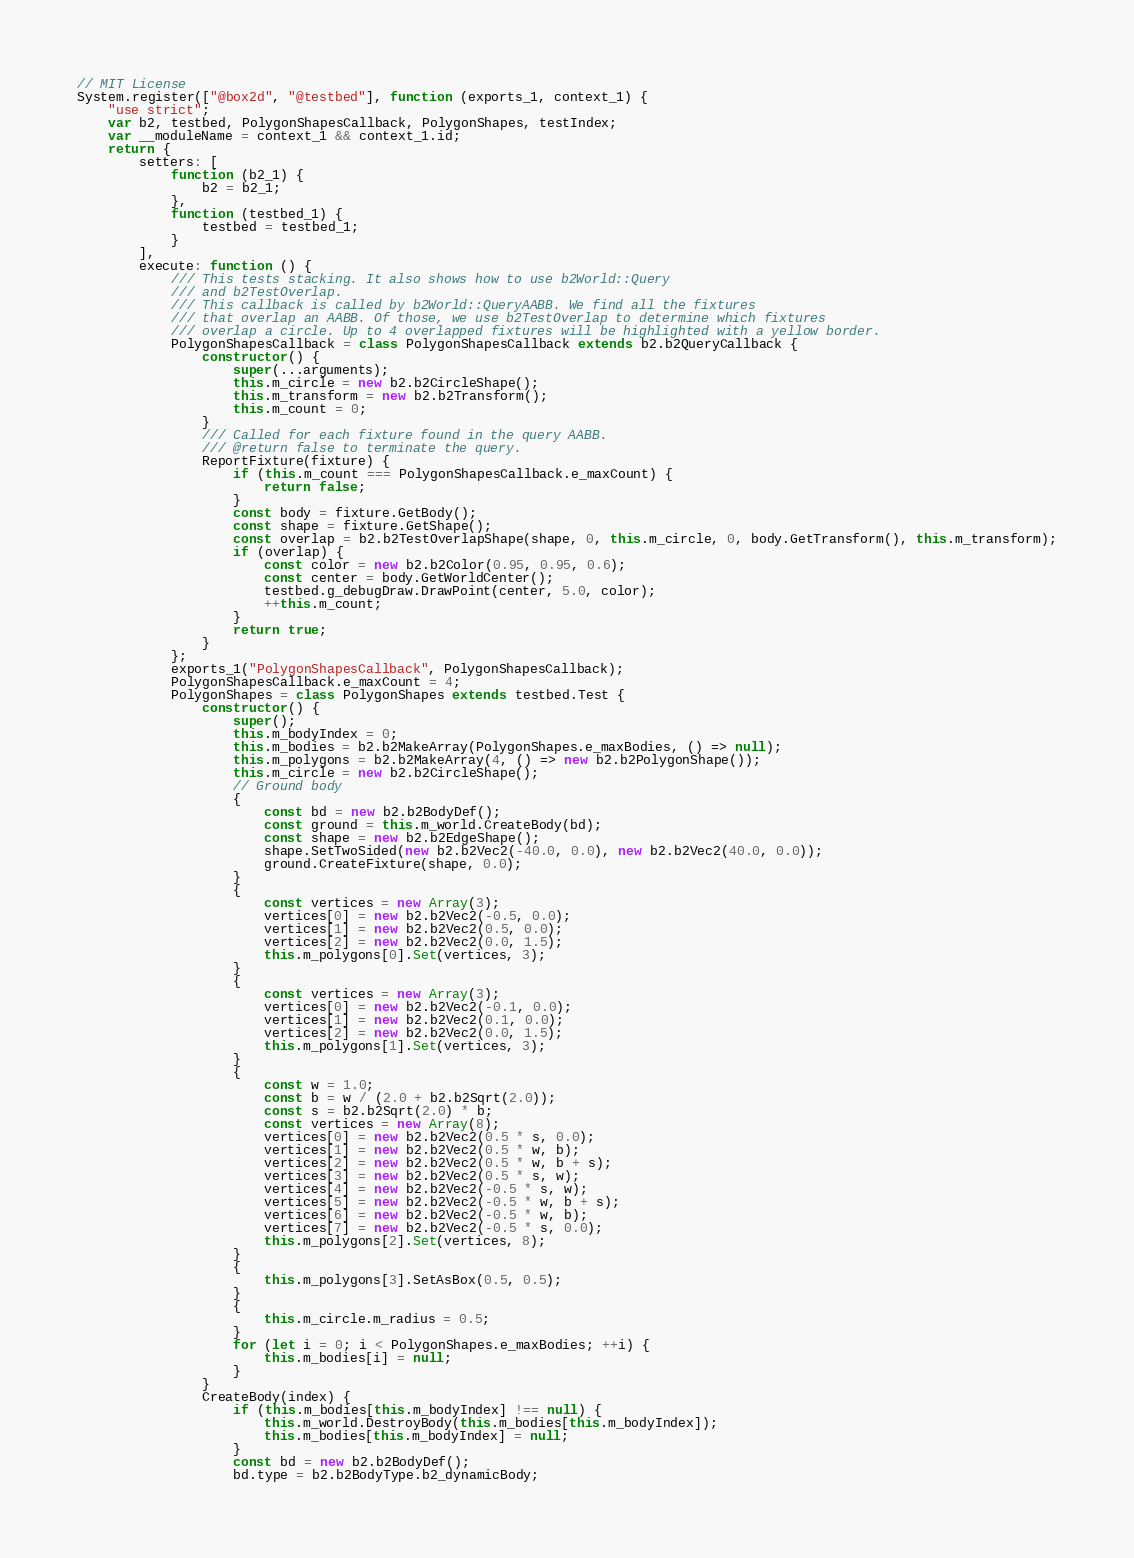Convert code to text. <code><loc_0><loc_0><loc_500><loc_500><_JavaScript_>// MIT License
System.register(["@box2d", "@testbed"], function (exports_1, context_1) {
    "use strict";
    var b2, testbed, PolygonShapesCallback, PolygonShapes, testIndex;
    var __moduleName = context_1 && context_1.id;
    return {
        setters: [
            function (b2_1) {
                b2 = b2_1;
            },
            function (testbed_1) {
                testbed = testbed_1;
            }
        ],
        execute: function () {
            /// This tests stacking. It also shows how to use b2World::Query
            /// and b2TestOverlap.
            /// This callback is called by b2World::QueryAABB. We find all the fixtures
            /// that overlap an AABB. Of those, we use b2TestOverlap to determine which fixtures
            /// overlap a circle. Up to 4 overlapped fixtures will be highlighted with a yellow border.
            PolygonShapesCallback = class PolygonShapesCallback extends b2.b2QueryCallback {
                constructor() {
                    super(...arguments);
                    this.m_circle = new b2.b2CircleShape();
                    this.m_transform = new b2.b2Transform();
                    this.m_count = 0;
                }
                /// Called for each fixture found in the query AABB.
                /// @return false to terminate the query.
                ReportFixture(fixture) {
                    if (this.m_count === PolygonShapesCallback.e_maxCount) {
                        return false;
                    }
                    const body = fixture.GetBody();
                    const shape = fixture.GetShape();
                    const overlap = b2.b2TestOverlapShape(shape, 0, this.m_circle, 0, body.GetTransform(), this.m_transform);
                    if (overlap) {
                        const color = new b2.b2Color(0.95, 0.95, 0.6);
                        const center = body.GetWorldCenter();
                        testbed.g_debugDraw.DrawPoint(center, 5.0, color);
                        ++this.m_count;
                    }
                    return true;
                }
            };
            exports_1("PolygonShapesCallback", PolygonShapesCallback);
            PolygonShapesCallback.e_maxCount = 4;
            PolygonShapes = class PolygonShapes extends testbed.Test {
                constructor() {
                    super();
                    this.m_bodyIndex = 0;
                    this.m_bodies = b2.b2MakeArray(PolygonShapes.e_maxBodies, () => null);
                    this.m_polygons = b2.b2MakeArray(4, () => new b2.b2PolygonShape());
                    this.m_circle = new b2.b2CircleShape();
                    // Ground body
                    {
                        const bd = new b2.b2BodyDef();
                        const ground = this.m_world.CreateBody(bd);
                        const shape = new b2.b2EdgeShape();
                        shape.SetTwoSided(new b2.b2Vec2(-40.0, 0.0), new b2.b2Vec2(40.0, 0.0));
                        ground.CreateFixture(shape, 0.0);
                    }
                    {
                        const vertices = new Array(3);
                        vertices[0] = new b2.b2Vec2(-0.5, 0.0);
                        vertices[1] = new b2.b2Vec2(0.5, 0.0);
                        vertices[2] = new b2.b2Vec2(0.0, 1.5);
                        this.m_polygons[0].Set(vertices, 3);
                    }
                    {
                        const vertices = new Array(3);
                        vertices[0] = new b2.b2Vec2(-0.1, 0.0);
                        vertices[1] = new b2.b2Vec2(0.1, 0.0);
                        vertices[2] = new b2.b2Vec2(0.0, 1.5);
                        this.m_polygons[1].Set(vertices, 3);
                    }
                    {
                        const w = 1.0;
                        const b = w / (2.0 + b2.b2Sqrt(2.0));
                        const s = b2.b2Sqrt(2.0) * b;
                        const vertices = new Array(8);
                        vertices[0] = new b2.b2Vec2(0.5 * s, 0.0);
                        vertices[1] = new b2.b2Vec2(0.5 * w, b);
                        vertices[2] = new b2.b2Vec2(0.5 * w, b + s);
                        vertices[3] = new b2.b2Vec2(0.5 * s, w);
                        vertices[4] = new b2.b2Vec2(-0.5 * s, w);
                        vertices[5] = new b2.b2Vec2(-0.5 * w, b + s);
                        vertices[6] = new b2.b2Vec2(-0.5 * w, b);
                        vertices[7] = new b2.b2Vec2(-0.5 * s, 0.0);
                        this.m_polygons[2].Set(vertices, 8);
                    }
                    {
                        this.m_polygons[3].SetAsBox(0.5, 0.5);
                    }
                    {
                        this.m_circle.m_radius = 0.5;
                    }
                    for (let i = 0; i < PolygonShapes.e_maxBodies; ++i) {
                        this.m_bodies[i] = null;
                    }
                }
                CreateBody(index) {
                    if (this.m_bodies[this.m_bodyIndex] !== null) {
                        this.m_world.DestroyBody(this.m_bodies[this.m_bodyIndex]);
                        this.m_bodies[this.m_bodyIndex] = null;
                    }
                    const bd = new b2.b2BodyDef();
                    bd.type = b2.b2BodyType.b2_dynamicBody;</code> 